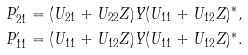<formula> <loc_0><loc_0><loc_500><loc_500>P ^ { \prime } _ { 2 1 } & = ( U _ { 2 1 } + U _ { 2 2 } Z ) Y ( U _ { 1 1 } + U _ { 1 2 } Z ) ^ { * } , \\ P ^ { \prime } _ { 1 1 } & = ( U _ { 1 1 } + U _ { 1 2 } Z ) Y ( U _ { 1 1 } + U _ { 1 2 } Z ) ^ { * } .</formula> 